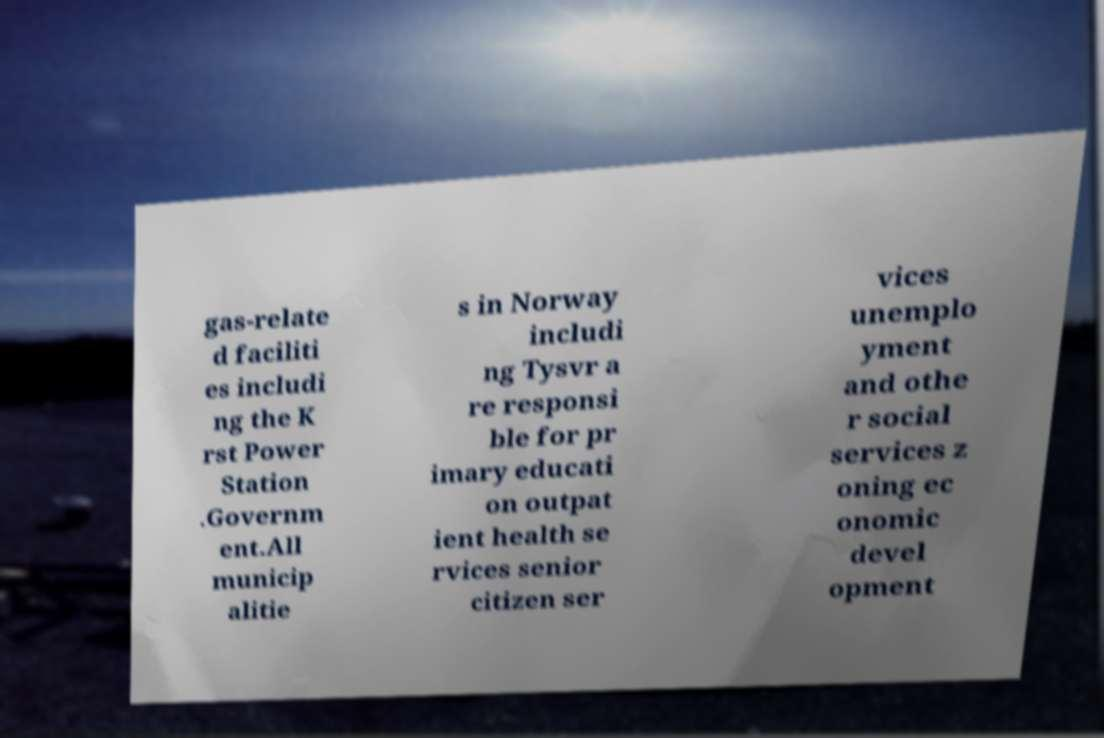For documentation purposes, I need the text within this image transcribed. Could you provide that? gas-relate d faciliti es includi ng the K rst Power Station .Governm ent.All municip alitie s in Norway includi ng Tysvr a re responsi ble for pr imary educati on outpat ient health se rvices senior citizen ser vices unemplo yment and othe r social services z oning ec onomic devel opment 